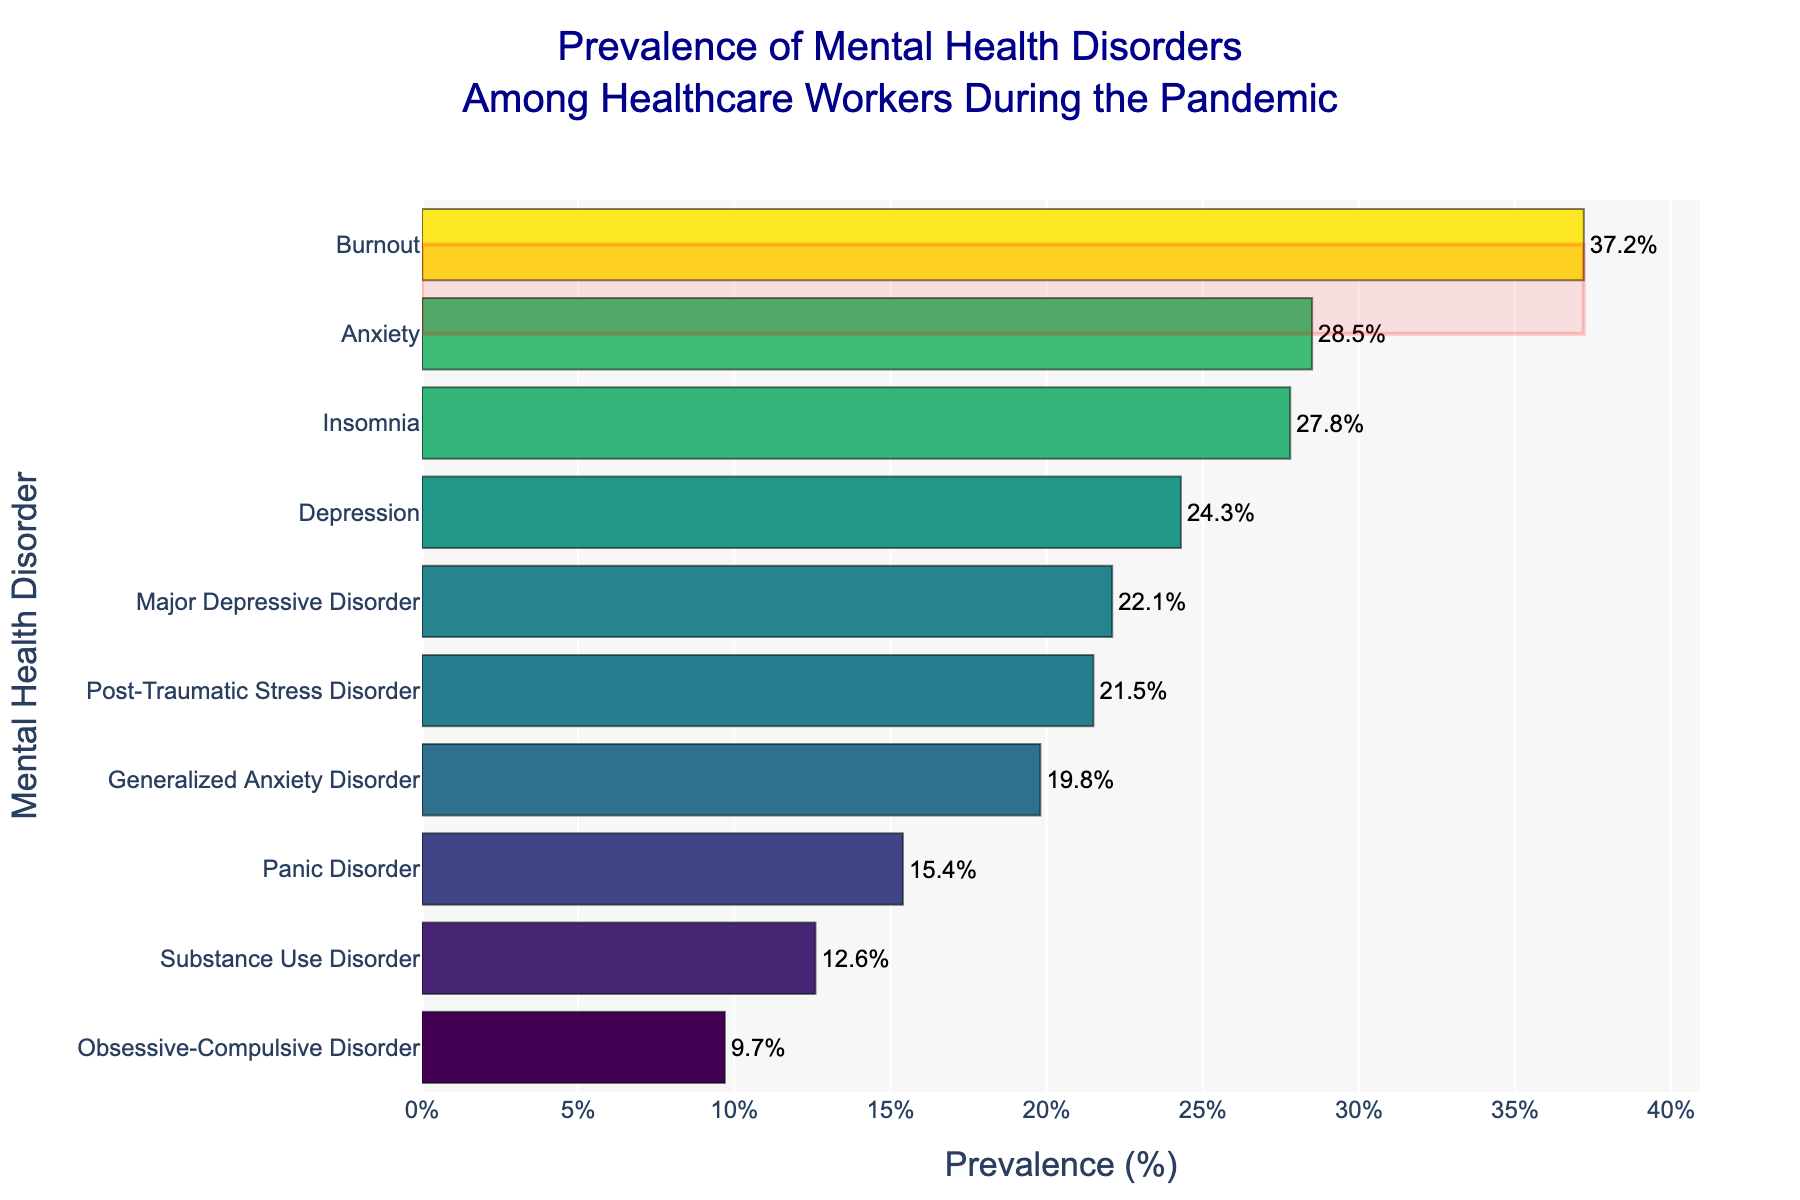what is the title of the figure? The title is shown at the top of the figure, typically centered, indicating the main topic or focus of the data. In this case, it reads as: "Prevalence of Mental Health Disorders Among Healthcare Workers During the Pandemic".
Answer: Prevalence of Mental Health Disorders Among Healthcare Workers During the Pandemic Which mental health disorder has the highest prevalence? By examining the bars in the figure, we can see that the longest bar represents the disorder with the highest prevalence. The disorder here is "Burnout", which has a 37.2% prevalence.
Answer: Burnout How many mental health disorders have a prevalence greater than 20%? To determine this, we look for bars that extend past the 20% mark on the x-axis. Counting these, we find the following disorders: Anxiety, Depression, Insomnia, Burnout, and Generalized Anxiety Disorder. There are 5 such disorders.
Answer: 5 What is the prevalence of Insomnia? The figure displays each disorder along with the prevalence percentage at the end of each bar. For Insomnia, this percentage is represented as 27.8%.
Answer: 27.8% How does the prevalence of Major Depressive Disorder compare to that of Panic Disorder? We need to compare the lengths of the respective bars or the prevalence percentages displayed. Major Depressive Disorder has a prevalence of 22.1%, while Panic Disorder has 15.4%. Hence, Major Depressive Disorder has a higher prevalence than Panic Disorder.
Answer: Major Depressive Disorder has a higher prevalence What is the difference in prevalence between Anxiety and Substance Use Disorder? Find the prevalence of Anxiety and Substance Use Disorder from the figure. Anxiety has 28.5% and Substance Use Disorder has 12.6%. The difference is calculated as 28.5% - 12.6% = 15.9%.
Answer: 15.9% Which disorders have a prevalence between 10% and 25%? To find these, look for bars that fall within the 10%-25% range on the x-axis. These disorders are Depression (24.3%), Insomnia (27.8%), Generalized Anxiety Disorder (19.8%), Post-Traumatic Stress Disorder (21.5%), Panic Disorder (15.4%), and Substance Use Disorder (12.6%).
Answer: Panic Disorder, Substance Use Disorder, Post-Traumatic Stress Disorder, and Major Depressive Disorder What is the total prevalence of Generalized Anxiety Disorder and Major Depressive Disorder? Find the prevalence of each from the figure and sum them. Generalized Anxiety Disorder: 19.8%, Major Depressive Disorder: 22.1%. Adding them gives 19.8% + 22.1% = 41.9%.
Answer: 41.9% Which disorder is depicted with the least prevalence? The smallest bar on the figure represents the disorder with the least prevalence. In this figure, that is "Obsessive-Compulsive Disorder" which has a prevalence of 9.7%.
Answer: Obsessive-Compulsive Disorder 